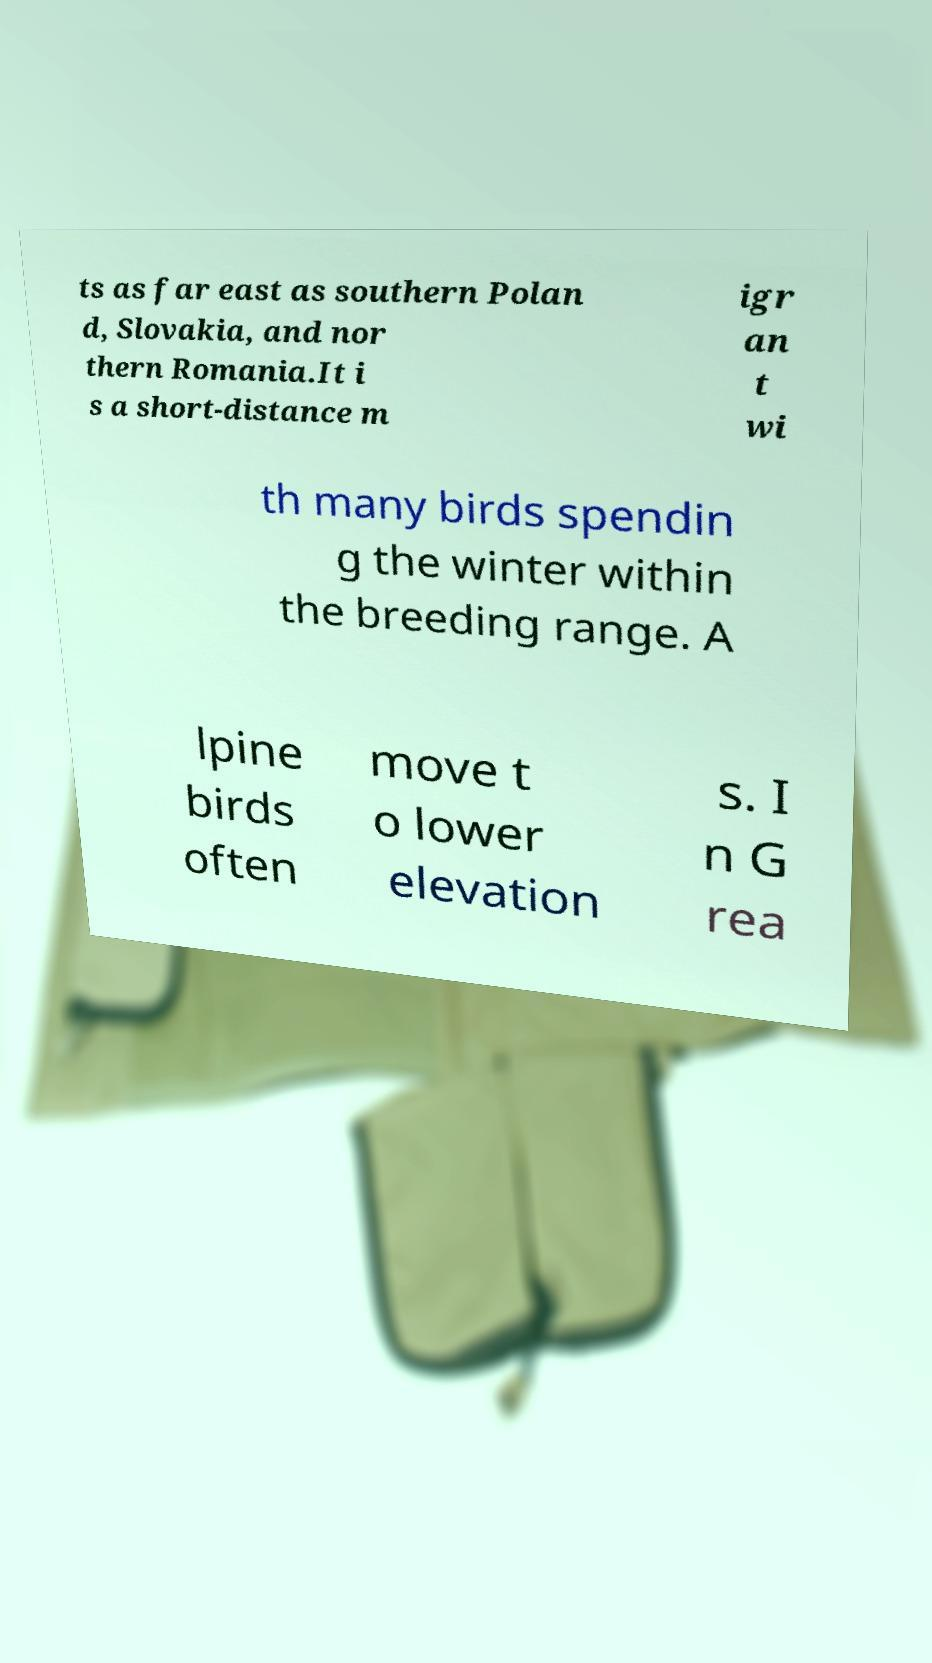Please identify and transcribe the text found in this image. ts as far east as southern Polan d, Slovakia, and nor thern Romania.It i s a short-distance m igr an t wi th many birds spendin g the winter within the breeding range. A lpine birds often move t o lower elevation s. I n G rea 